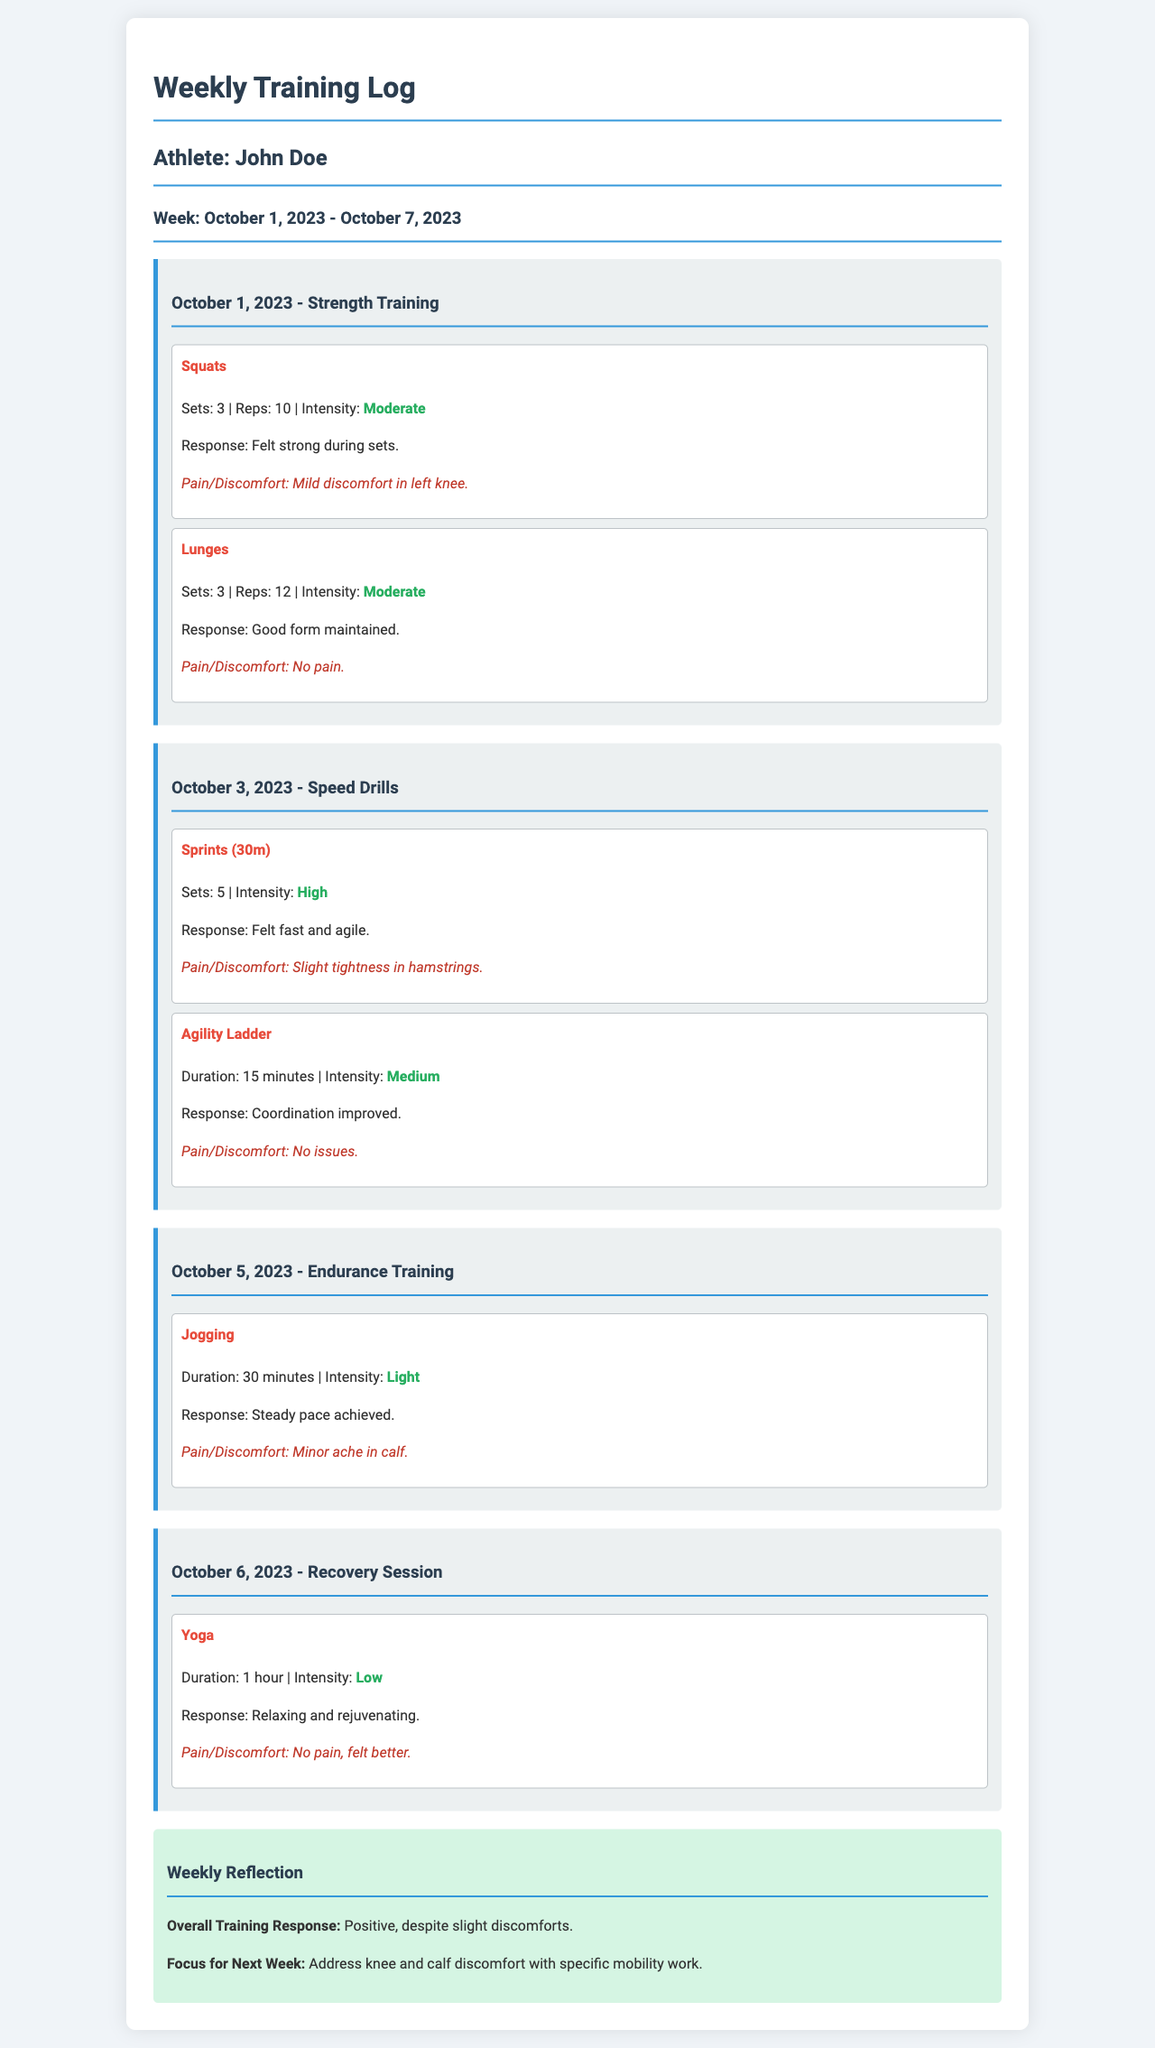What is the name of the athlete? The document identifies the athlete as John Doe.
Answer: John Doe What was the intensity of the lunges exercise? The lunges were performed with a moderate intensity level, as stated in the document.
Answer: Moderate How many sets of sprints were completed? The document states that there were a total of 5 sets of sprints performed.
Answer: 5 What was the response to the jogging session? The document mentions that a steady pace was achieved during the jogging session.
Answer: Steady pace achieved What discomfort was noted after the strength training session? The document indicates there was mild discomfort in the left knee after strength training.
Answer: Mild discomfort in left knee Which exercise was performed on October 6, 2023? The document lists yoga as the exercise performed on October 6, 2023.
Answer: Yoga What was the focus for next week? The focus for the next week is to address knee and calf discomfort with specific mobility work.
Answer: Address knee and calf discomfort What is the duration of the yoga session? The duration for the yoga session is specified as 1 hour in the document.
Answer: 1 hour Was there any pain reported during the agility ladder exercise? The document confirms that there were no issues reported during the agility ladder exercise.
Answer: No issues 